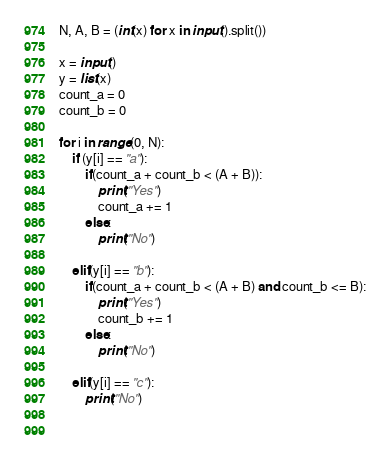Convert code to text. <code><loc_0><loc_0><loc_500><loc_500><_Python_>N, A, B = (int(x) for x in input().split())

x = input()
y = list(x)
count_a = 0
count_b = 0

for i in range(0, N):
    if (y[i] == "a"):
        if(count_a + count_b < (A + B)):
            print("Yes")
            count_a += 1
        else:
            print("No")
    
    elif(y[i] == "b"):
        if(count_a + count_b < (A + B) and count_b <= B):
            print("Yes")
            count_b += 1
        else:
            print("No")
    
    elif(y[i] == "c"):
        print("No")

    </code> 